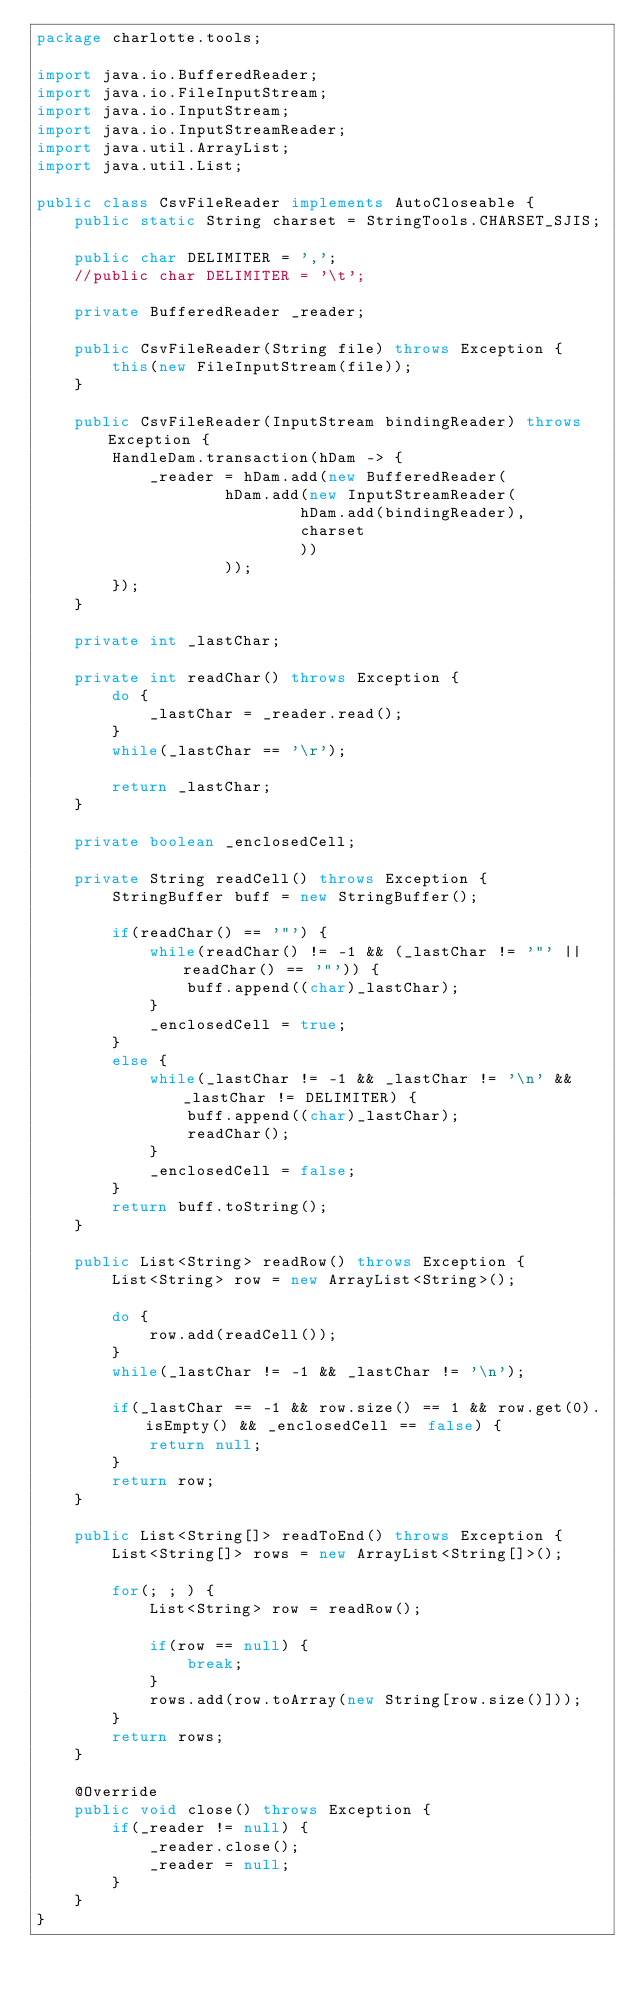<code> <loc_0><loc_0><loc_500><loc_500><_Java_>package charlotte.tools;

import java.io.BufferedReader;
import java.io.FileInputStream;
import java.io.InputStream;
import java.io.InputStreamReader;
import java.util.ArrayList;
import java.util.List;

public class CsvFileReader implements AutoCloseable {
	public static String charset = StringTools.CHARSET_SJIS;

	public char DELIMITER = ',';
	//public char DELIMITER = '\t';

	private BufferedReader _reader;

	public CsvFileReader(String file) throws Exception {
		this(new FileInputStream(file));
	}

	public CsvFileReader(InputStream bindingReader) throws Exception {
		HandleDam.transaction(hDam -> {
			_reader = hDam.add(new BufferedReader(
					hDam.add(new InputStreamReader(
							hDam.add(bindingReader),
							charset
							))
					));
		});
	}

	private int _lastChar;

	private int readChar() throws Exception {
		do {
			_lastChar = _reader.read();
		}
		while(_lastChar == '\r');

		return _lastChar;
	}

	private boolean _enclosedCell;

	private String readCell() throws Exception {
		StringBuffer buff = new StringBuffer();

		if(readChar() == '"') {
			while(readChar() != -1 && (_lastChar != '"' || readChar() == '"')) {
				buff.append((char)_lastChar);
			}
			_enclosedCell = true;
		}
		else {
			while(_lastChar != -1 && _lastChar != '\n' && _lastChar != DELIMITER) {
				buff.append((char)_lastChar);
				readChar();
			}
			_enclosedCell = false;
		}
		return buff.toString();
	}

	public List<String> readRow() throws Exception {
		List<String> row = new ArrayList<String>();

		do {
			row.add(readCell());
		}
		while(_lastChar != -1 && _lastChar != '\n');

		if(_lastChar == -1 && row.size() == 1 && row.get(0).isEmpty() && _enclosedCell == false) {
			return null;
		}
		return row;
	}

	public List<String[]> readToEnd() throws Exception {
		List<String[]> rows = new ArrayList<String[]>();

		for(; ; ) {
			List<String> row = readRow();

			if(row == null) {
				break;
			}
			rows.add(row.toArray(new String[row.size()]));
		}
		return rows;
	}

	@Override
	public void close() throws Exception {
		if(_reader != null) {
			_reader.close();
			_reader = null;
		}
	}
}
</code> 